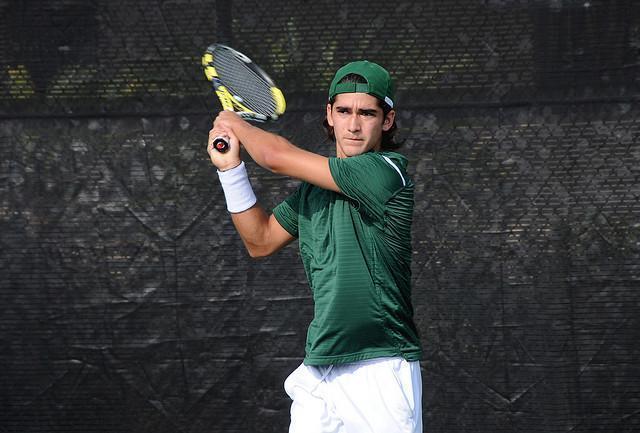How many pictures of horses are there?
Give a very brief answer. 0. 